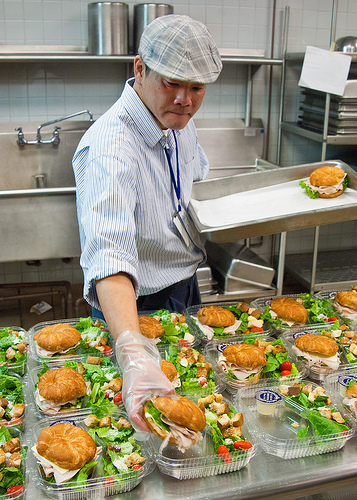<image>
Is there a tap behind the man? Yes. From this viewpoint, the tap is positioned behind the man, with the man partially or fully occluding the tap. 